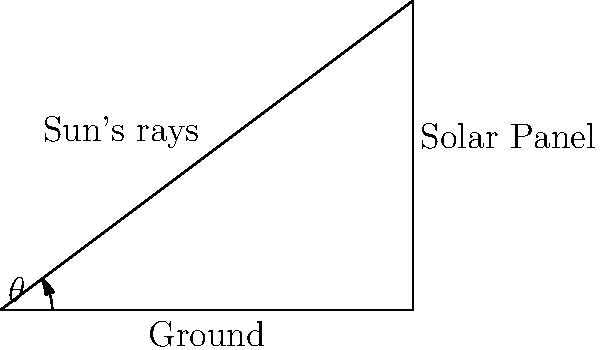As part of a government initiative to increase renewable energy usage in Berlin, you've been tasked with determining the optimal angle for solar panels on government buildings. Given that the efficiency of solar panels is highest when they are perpendicular to the sun's rays, and using the diagram provided, calculate the optimal angle $\theta$ for the solar panels. Assume that the ground is represented by a 4-unit length, and the height of the panel is 3 units. Express your answer in degrees, rounded to the nearest whole number. To solve this problem, we'll use trigonometric identities and follow these steps:

1) In the right triangle formed, we know:
   - The adjacent side (ground) is 4 units
   - The opposite side (height) is 3 units

2) We can use the tangent function to find the angle $\theta$:

   $$\tan(\theta) = \frac{\text{opposite}}{\text{adjacent}} = \frac{3}{4}$$

3) To find $\theta$, we need to use the inverse tangent (arctangent) function:

   $$\theta = \arctan(\frac{3}{4})$$

4) Using a calculator or mathematical software:

   $$\theta \approx 36.87°$$

5) Rounding to the nearest whole number:

   $$\theta \approx 37°$$

6) However, this is not the optimal angle for the solar panels. The optimal angle is when the panels are perpendicular to the sun's rays, which is complementary to the angle we just calculated.

7) The optimal angle is:

   $$90° - 37° = 53°$$

Therefore, the optimal angle for the solar panels is approximately 53°.
Answer: 53° 